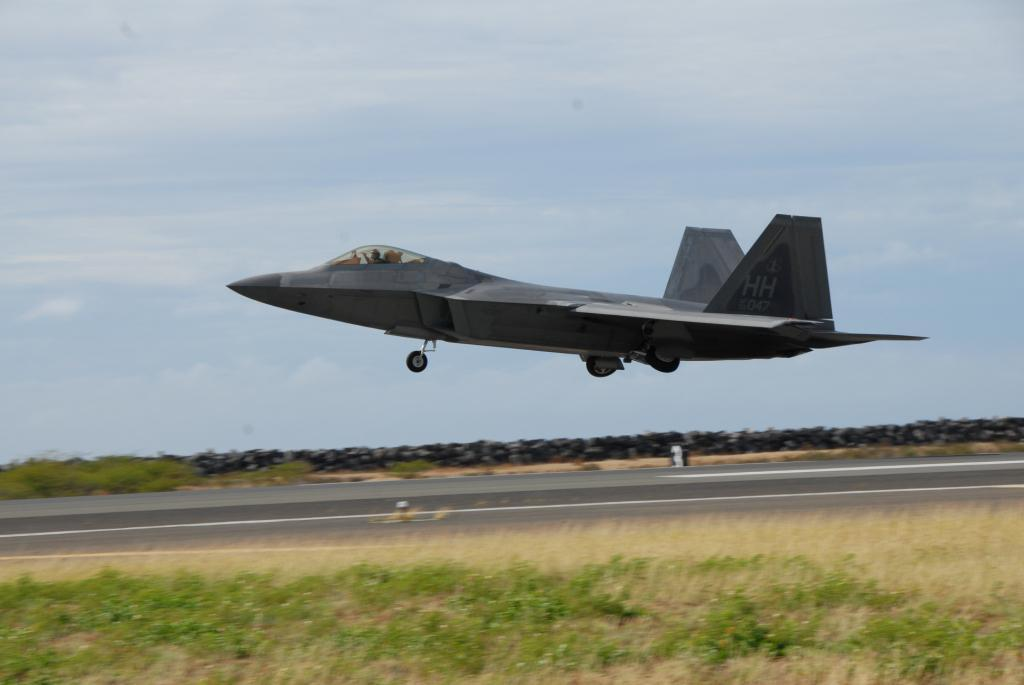What is the main subject of the image? The main subject of the image is an airplane flying. What type of terrain can be seen in the image? There is grass visible in the image. What type of structure is present in the image? There is a wall in the image. What type of pathway is visible in the image? There is a road in the image. What can be seen in the background of the image? The sky with clouds is visible in the background of the image. What type of car operation is being performed in the image? There is no car or operation present in the image; it features an airplane flying. How much debt is visible in the image? There is: There is no mention of debt in the image; it focuses on the airplane, grass, wall, road, and sky with clouds. 